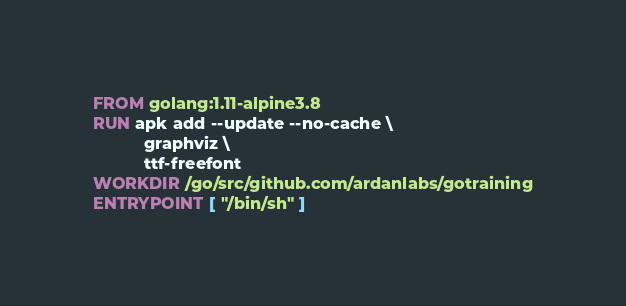Convert code to text. <code><loc_0><loc_0><loc_500><loc_500><_Dockerfile_>FROM golang:1.11-alpine3.8
RUN apk add --update --no-cache \
           graphviz \
           ttf-freefont
WORKDIR /go/src/github.com/ardanlabs/gotraining
ENTRYPOINT [ "/bin/sh" ]
</code> 